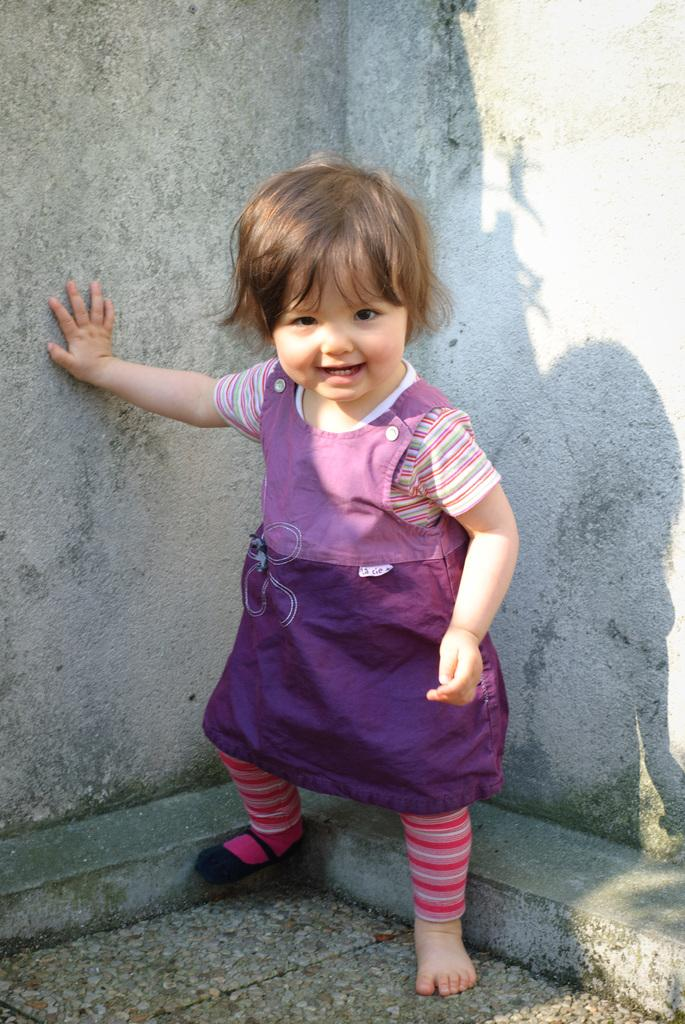What is the main subject of the image? The main subject of the image is a kid. Where is the kid located in the image? The kid is standing near a wall. What type of quill is the kid holding in the image? There is no quill present in the image. What sense does the kid appear to be using while standing near the wall? The image does not provide information about the kid's senses or actions, so it cannot be determined from the image. 